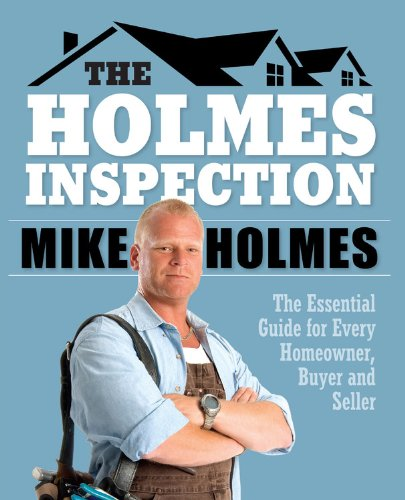Is this book related to Teen & Young Adult? No, the content of this book is tailored for adults, focusing on homeownership, which isn't typically aligned with teen and young adult interests. 